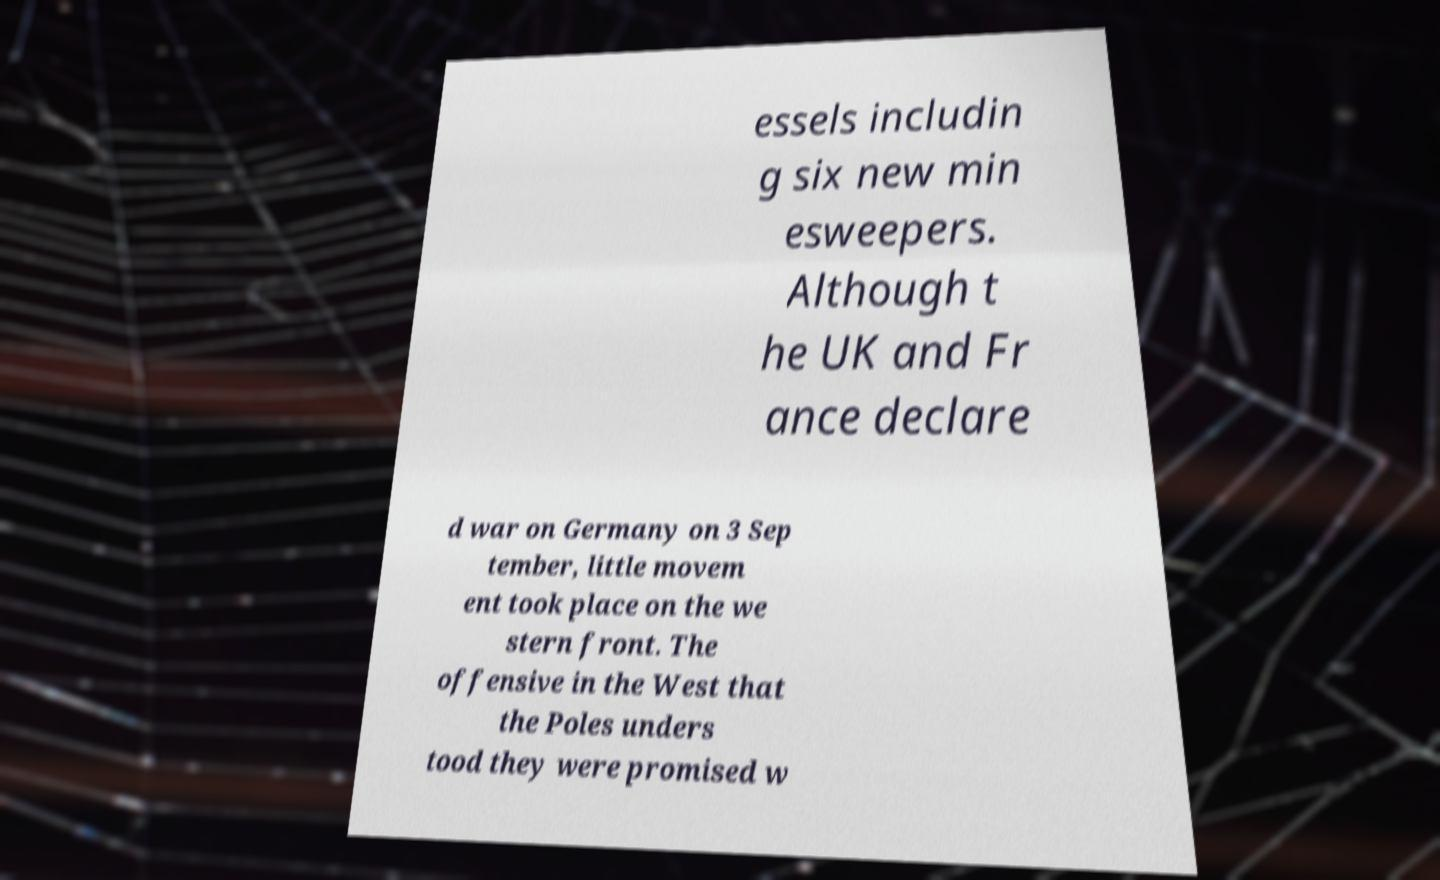Please read and relay the text visible in this image. What does it say? essels includin g six new min esweepers. Although t he UK and Fr ance declare d war on Germany on 3 Sep tember, little movem ent took place on the we stern front. The offensive in the West that the Poles unders tood they were promised w 